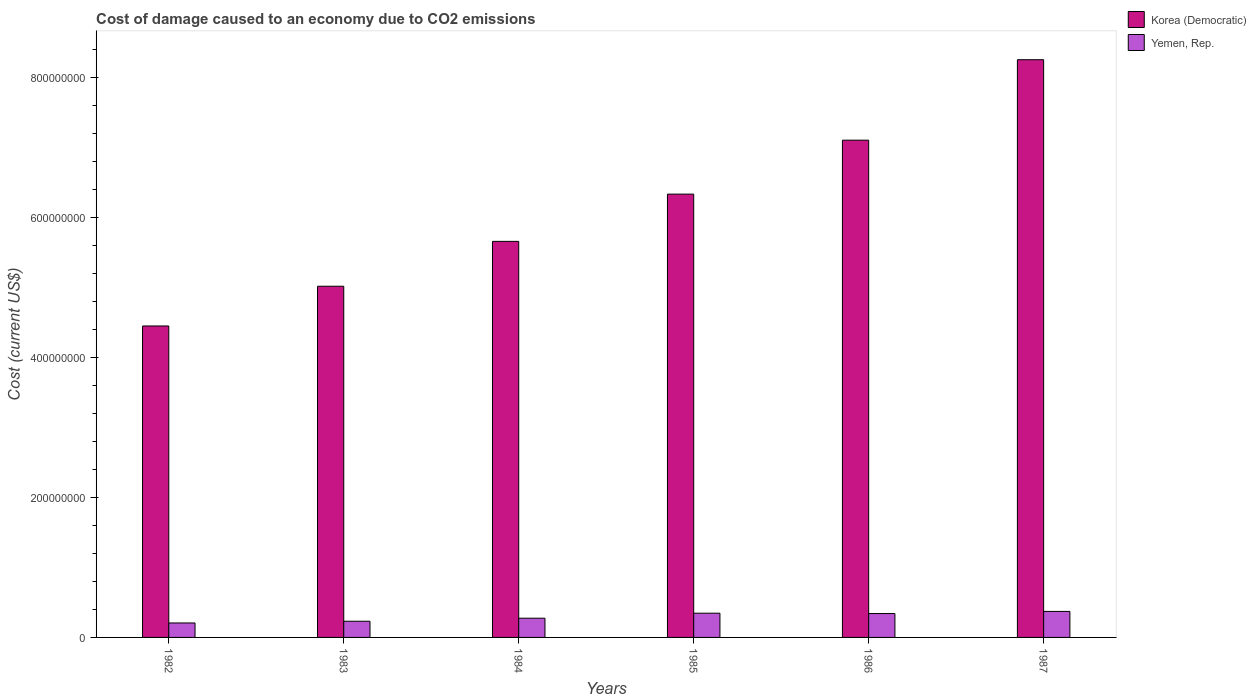How many bars are there on the 4th tick from the left?
Offer a terse response. 2. How many bars are there on the 6th tick from the right?
Ensure brevity in your answer.  2. What is the label of the 3rd group of bars from the left?
Your answer should be very brief. 1984. In how many cases, is the number of bars for a given year not equal to the number of legend labels?
Your response must be concise. 0. What is the cost of damage caused due to CO2 emissisons in Korea (Democratic) in 1986?
Provide a succinct answer. 7.10e+08. Across all years, what is the maximum cost of damage caused due to CO2 emissisons in Yemen, Rep.?
Make the answer very short. 3.72e+07. Across all years, what is the minimum cost of damage caused due to CO2 emissisons in Korea (Democratic)?
Make the answer very short. 4.45e+08. In which year was the cost of damage caused due to CO2 emissisons in Korea (Democratic) maximum?
Ensure brevity in your answer.  1987. In which year was the cost of damage caused due to CO2 emissisons in Yemen, Rep. minimum?
Keep it short and to the point. 1982. What is the total cost of damage caused due to CO2 emissisons in Korea (Democratic) in the graph?
Your answer should be compact. 3.68e+09. What is the difference between the cost of damage caused due to CO2 emissisons in Yemen, Rep. in 1985 and that in 1987?
Ensure brevity in your answer.  -2.56e+06. What is the difference between the cost of damage caused due to CO2 emissisons in Yemen, Rep. in 1982 and the cost of damage caused due to CO2 emissisons in Korea (Democratic) in 1987?
Give a very brief answer. -8.04e+08. What is the average cost of damage caused due to CO2 emissisons in Korea (Democratic) per year?
Offer a terse response. 6.13e+08. In the year 1984, what is the difference between the cost of damage caused due to CO2 emissisons in Yemen, Rep. and cost of damage caused due to CO2 emissisons in Korea (Democratic)?
Make the answer very short. -5.38e+08. What is the ratio of the cost of damage caused due to CO2 emissisons in Yemen, Rep. in 1983 to that in 1985?
Keep it short and to the point. 0.67. Is the cost of damage caused due to CO2 emissisons in Yemen, Rep. in 1985 less than that in 1987?
Offer a very short reply. Yes. What is the difference between the highest and the second highest cost of damage caused due to CO2 emissisons in Yemen, Rep.?
Provide a succinct answer. 2.56e+06. What is the difference between the highest and the lowest cost of damage caused due to CO2 emissisons in Yemen, Rep.?
Offer a terse response. 1.65e+07. Is the sum of the cost of damage caused due to CO2 emissisons in Korea (Democratic) in 1983 and 1987 greater than the maximum cost of damage caused due to CO2 emissisons in Yemen, Rep. across all years?
Offer a terse response. Yes. What does the 1st bar from the left in 1987 represents?
Make the answer very short. Korea (Democratic). What does the 2nd bar from the right in 1985 represents?
Provide a succinct answer. Korea (Democratic). How many years are there in the graph?
Your response must be concise. 6. Where does the legend appear in the graph?
Provide a succinct answer. Top right. How are the legend labels stacked?
Offer a very short reply. Vertical. What is the title of the graph?
Your answer should be compact. Cost of damage caused to an economy due to CO2 emissions. What is the label or title of the Y-axis?
Keep it short and to the point. Cost (current US$). What is the Cost (current US$) of Korea (Democratic) in 1982?
Provide a succinct answer. 4.45e+08. What is the Cost (current US$) in Yemen, Rep. in 1982?
Provide a short and direct response. 2.07e+07. What is the Cost (current US$) of Korea (Democratic) in 1983?
Offer a terse response. 5.02e+08. What is the Cost (current US$) of Yemen, Rep. in 1983?
Your answer should be very brief. 2.31e+07. What is the Cost (current US$) of Korea (Democratic) in 1984?
Your answer should be compact. 5.66e+08. What is the Cost (current US$) in Yemen, Rep. in 1984?
Ensure brevity in your answer.  2.74e+07. What is the Cost (current US$) in Korea (Democratic) in 1985?
Provide a short and direct response. 6.33e+08. What is the Cost (current US$) in Yemen, Rep. in 1985?
Ensure brevity in your answer.  3.46e+07. What is the Cost (current US$) in Korea (Democratic) in 1986?
Keep it short and to the point. 7.10e+08. What is the Cost (current US$) of Yemen, Rep. in 1986?
Your response must be concise. 3.41e+07. What is the Cost (current US$) of Korea (Democratic) in 1987?
Your answer should be very brief. 8.25e+08. What is the Cost (current US$) of Yemen, Rep. in 1987?
Offer a very short reply. 3.72e+07. Across all years, what is the maximum Cost (current US$) in Korea (Democratic)?
Offer a very short reply. 8.25e+08. Across all years, what is the maximum Cost (current US$) in Yemen, Rep.?
Ensure brevity in your answer.  3.72e+07. Across all years, what is the minimum Cost (current US$) of Korea (Democratic)?
Offer a very short reply. 4.45e+08. Across all years, what is the minimum Cost (current US$) in Yemen, Rep.?
Your response must be concise. 2.07e+07. What is the total Cost (current US$) in Korea (Democratic) in the graph?
Your answer should be compact. 3.68e+09. What is the total Cost (current US$) of Yemen, Rep. in the graph?
Your answer should be very brief. 1.77e+08. What is the difference between the Cost (current US$) of Korea (Democratic) in 1982 and that in 1983?
Keep it short and to the point. -5.67e+07. What is the difference between the Cost (current US$) of Yemen, Rep. in 1982 and that in 1983?
Ensure brevity in your answer.  -2.46e+06. What is the difference between the Cost (current US$) of Korea (Democratic) in 1982 and that in 1984?
Offer a terse response. -1.21e+08. What is the difference between the Cost (current US$) in Yemen, Rep. in 1982 and that in 1984?
Your answer should be compact. -6.79e+06. What is the difference between the Cost (current US$) in Korea (Democratic) in 1982 and that in 1985?
Give a very brief answer. -1.88e+08. What is the difference between the Cost (current US$) of Yemen, Rep. in 1982 and that in 1985?
Provide a succinct answer. -1.39e+07. What is the difference between the Cost (current US$) in Korea (Democratic) in 1982 and that in 1986?
Give a very brief answer. -2.65e+08. What is the difference between the Cost (current US$) of Yemen, Rep. in 1982 and that in 1986?
Ensure brevity in your answer.  -1.34e+07. What is the difference between the Cost (current US$) of Korea (Democratic) in 1982 and that in 1987?
Provide a short and direct response. -3.80e+08. What is the difference between the Cost (current US$) in Yemen, Rep. in 1982 and that in 1987?
Make the answer very short. -1.65e+07. What is the difference between the Cost (current US$) in Korea (Democratic) in 1983 and that in 1984?
Keep it short and to the point. -6.41e+07. What is the difference between the Cost (current US$) of Yemen, Rep. in 1983 and that in 1984?
Give a very brief answer. -4.33e+06. What is the difference between the Cost (current US$) in Korea (Democratic) in 1983 and that in 1985?
Your response must be concise. -1.32e+08. What is the difference between the Cost (current US$) in Yemen, Rep. in 1983 and that in 1985?
Keep it short and to the point. -1.15e+07. What is the difference between the Cost (current US$) in Korea (Democratic) in 1983 and that in 1986?
Provide a succinct answer. -2.09e+08. What is the difference between the Cost (current US$) in Yemen, Rep. in 1983 and that in 1986?
Keep it short and to the point. -1.10e+07. What is the difference between the Cost (current US$) in Korea (Democratic) in 1983 and that in 1987?
Offer a terse response. -3.24e+08. What is the difference between the Cost (current US$) of Yemen, Rep. in 1983 and that in 1987?
Provide a short and direct response. -1.40e+07. What is the difference between the Cost (current US$) in Korea (Democratic) in 1984 and that in 1985?
Your response must be concise. -6.75e+07. What is the difference between the Cost (current US$) in Yemen, Rep. in 1984 and that in 1985?
Ensure brevity in your answer.  -7.15e+06. What is the difference between the Cost (current US$) of Korea (Democratic) in 1984 and that in 1986?
Your response must be concise. -1.45e+08. What is the difference between the Cost (current US$) of Yemen, Rep. in 1984 and that in 1986?
Offer a terse response. -6.65e+06. What is the difference between the Cost (current US$) of Korea (Democratic) in 1984 and that in 1987?
Make the answer very short. -2.59e+08. What is the difference between the Cost (current US$) in Yemen, Rep. in 1984 and that in 1987?
Provide a short and direct response. -9.71e+06. What is the difference between the Cost (current US$) of Korea (Democratic) in 1985 and that in 1986?
Offer a very short reply. -7.70e+07. What is the difference between the Cost (current US$) in Yemen, Rep. in 1985 and that in 1986?
Ensure brevity in your answer.  4.90e+05. What is the difference between the Cost (current US$) in Korea (Democratic) in 1985 and that in 1987?
Provide a succinct answer. -1.92e+08. What is the difference between the Cost (current US$) in Yemen, Rep. in 1985 and that in 1987?
Ensure brevity in your answer.  -2.56e+06. What is the difference between the Cost (current US$) of Korea (Democratic) in 1986 and that in 1987?
Offer a very short reply. -1.15e+08. What is the difference between the Cost (current US$) in Yemen, Rep. in 1986 and that in 1987?
Your answer should be very brief. -3.05e+06. What is the difference between the Cost (current US$) of Korea (Democratic) in 1982 and the Cost (current US$) of Yemen, Rep. in 1983?
Provide a short and direct response. 4.22e+08. What is the difference between the Cost (current US$) of Korea (Democratic) in 1982 and the Cost (current US$) of Yemen, Rep. in 1984?
Give a very brief answer. 4.17e+08. What is the difference between the Cost (current US$) in Korea (Democratic) in 1982 and the Cost (current US$) in Yemen, Rep. in 1985?
Offer a terse response. 4.10e+08. What is the difference between the Cost (current US$) of Korea (Democratic) in 1982 and the Cost (current US$) of Yemen, Rep. in 1986?
Your response must be concise. 4.11e+08. What is the difference between the Cost (current US$) of Korea (Democratic) in 1982 and the Cost (current US$) of Yemen, Rep. in 1987?
Provide a succinct answer. 4.08e+08. What is the difference between the Cost (current US$) in Korea (Democratic) in 1983 and the Cost (current US$) in Yemen, Rep. in 1984?
Offer a terse response. 4.74e+08. What is the difference between the Cost (current US$) of Korea (Democratic) in 1983 and the Cost (current US$) of Yemen, Rep. in 1985?
Your answer should be compact. 4.67e+08. What is the difference between the Cost (current US$) of Korea (Democratic) in 1983 and the Cost (current US$) of Yemen, Rep. in 1986?
Offer a terse response. 4.67e+08. What is the difference between the Cost (current US$) of Korea (Democratic) in 1983 and the Cost (current US$) of Yemen, Rep. in 1987?
Offer a terse response. 4.64e+08. What is the difference between the Cost (current US$) of Korea (Democratic) in 1984 and the Cost (current US$) of Yemen, Rep. in 1985?
Your answer should be very brief. 5.31e+08. What is the difference between the Cost (current US$) in Korea (Democratic) in 1984 and the Cost (current US$) in Yemen, Rep. in 1986?
Your response must be concise. 5.32e+08. What is the difference between the Cost (current US$) in Korea (Democratic) in 1984 and the Cost (current US$) in Yemen, Rep. in 1987?
Offer a terse response. 5.28e+08. What is the difference between the Cost (current US$) of Korea (Democratic) in 1985 and the Cost (current US$) of Yemen, Rep. in 1986?
Provide a succinct answer. 5.99e+08. What is the difference between the Cost (current US$) in Korea (Democratic) in 1985 and the Cost (current US$) in Yemen, Rep. in 1987?
Keep it short and to the point. 5.96e+08. What is the difference between the Cost (current US$) in Korea (Democratic) in 1986 and the Cost (current US$) in Yemen, Rep. in 1987?
Provide a succinct answer. 6.73e+08. What is the average Cost (current US$) in Korea (Democratic) per year?
Ensure brevity in your answer.  6.13e+08. What is the average Cost (current US$) in Yemen, Rep. per year?
Ensure brevity in your answer.  2.95e+07. In the year 1982, what is the difference between the Cost (current US$) of Korea (Democratic) and Cost (current US$) of Yemen, Rep.?
Provide a succinct answer. 4.24e+08. In the year 1983, what is the difference between the Cost (current US$) in Korea (Democratic) and Cost (current US$) in Yemen, Rep.?
Offer a terse response. 4.78e+08. In the year 1984, what is the difference between the Cost (current US$) of Korea (Democratic) and Cost (current US$) of Yemen, Rep.?
Your response must be concise. 5.38e+08. In the year 1985, what is the difference between the Cost (current US$) in Korea (Democratic) and Cost (current US$) in Yemen, Rep.?
Ensure brevity in your answer.  5.98e+08. In the year 1986, what is the difference between the Cost (current US$) of Korea (Democratic) and Cost (current US$) of Yemen, Rep.?
Your answer should be compact. 6.76e+08. In the year 1987, what is the difference between the Cost (current US$) of Korea (Democratic) and Cost (current US$) of Yemen, Rep.?
Provide a short and direct response. 7.88e+08. What is the ratio of the Cost (current US$) of Korea (Democratic) in 1982 to that in 1983?
Make the answer very short. 0.89. What is the ratio of the Cost (current US$) of Yemen, Rep. in 1982 to that in 1983?
Offer a terse response. 0.89. What is the ratio of the Cost (current US$) in Korea (Democratic) in 1982 to that in 1984?
Provide a succinct answer. 0.79. What is the ratio of the Cost (current US$) in Yemen, Rep. in 1982 to that in 1984?
Make the answer very short. 0.75. What is the ratio of the Cost (current US$) of Korea (Democratic) in 1982 to that in 1985?
Provide a short and direct response. 0.7. What is the ratio of the Cost (current US$) in Yemen, Rep. in 1982 to that in 1985?
Provide a short and direct response. 0.6. What is the ratio of the Cost (current US$) in Korea (Democratic) in 1982 to that in 1986?
Give a very brief answer. 0.63. What is the ratio of the Cost (current US$) in Yemen, Rep. in 1982 to that in 1986?
Your response must be concise. 0.61. What is the ratio of the Cost (current US$) of Korea (Democratic) in 1982 to that in 1987?
Give a very brief answer. 0.54. What is the ratio of the Cost (current US$) of Yemen, Rep. in 1982 to that in 1987?
Give a very brief answer. 0.56. What is the ratio of the Cost (current US$) of Korea (Democratic) in 1983 to that in 1984?
Offer a very short reply. 0.89. What is the ratio of the Cost (current US$) of Yemen, Rep. in 1983 to that in 1984?
Give a very brief answer. 0.84. What is the ratio of the Cost (current US$) of Korea (Democratic) in 1983 to that in 1985?
Your answer should be very brief. 0.79. What is the ratio of the Cost (current US$) in Yemen, Rep. in 1983 to that in 1985?
Provide a succinct answer. 0.67. What is the ratio of the Cost (current US$) of Korea (Democratic) in 1983 to that in 1986?
Offer a terse response. 0.71. What is the ratio of the Cost (current US$) of Yemen, Rep. in 1983 to that in 1986?
Provide a succinct answer. 0.68. What is the ratio of the Cost (current US$) in Korea (Democratic) in 1983 to that in 1987?
Give a very brief answer. 0.61. What is the ratio of the Cost (current US$) in Yemen, Rep. in 1983 to that in 1987?
Make the answer very short. 0.62. What is the ratio of the Cost (current US$) of Korea (Democratic) in 1984 to that in 1985?
Provide a short and direct response. 0.89. What is the ratio of the Cost (current US$) of Yemen, Rep. in 1984 to that in 1985?
Offer a very short reply. 0.79. What is the ratio of the Cost (current US$) of Korea (Democratic) in 1984 to that in 1986?
Ensure brevity in your answer.  0.8. What is the ratio of the Cost (current US$) of Yemen, Rep. in 1984 to that in 1986?
Provide a succinct answer. 0.8. What is the ratio of the Cost (current US$) of Korea (Democratic) in 1984 to that in 1987?
Keep it short and to the point. 0.69. What is the ratio of the Cost (current US$) of Yemen, Rep. in 1984 to that in 1987?
Your answer should be very brief. 0.74. What is the ratio of the Cost (current US$) of Korea (Democratic) in 1985 to that in 1986?
Provide a succinct answer. 0.89. What is the ratio of the Cost (current US$) in Yemen, Rep. in 1985 to that in 1986?
Offer a terse response. 1.01. What is the ratio of the Cost (current US$) in Korea (Democratic) in 1985 to that in 1987?
Keep it short and to the point. 0.77. What is the ratio of the Cost (current US$) in Korea (Democratic) in 1986 to that in 1987?
Make the answer very short. 0.86. What is the ratio of the Cost (current US$) in Yemen, Rep. in 1986 to that in 1987?
Ensure brevity in your answer.  0.92. What is the difference between the highest and the second highest Cost (current US$) in Korea (Democratic)?
Ensure brevity in your answer.  1.15e+08. What is the difference between the highest and the second highest Cost (current US$) in Yemen, Rep.?
Provide a short and direct response. 2.56e+06. What is the difference between the highest and the lowest Cost (current US$) in Korea (Democratic)?
Offer a terse response. 3.80e+08. What is the difference between the highest and the lowest Cost (current US$) of Yemen, Rep.?
Provide a succinct answer. 1.65e+07. 